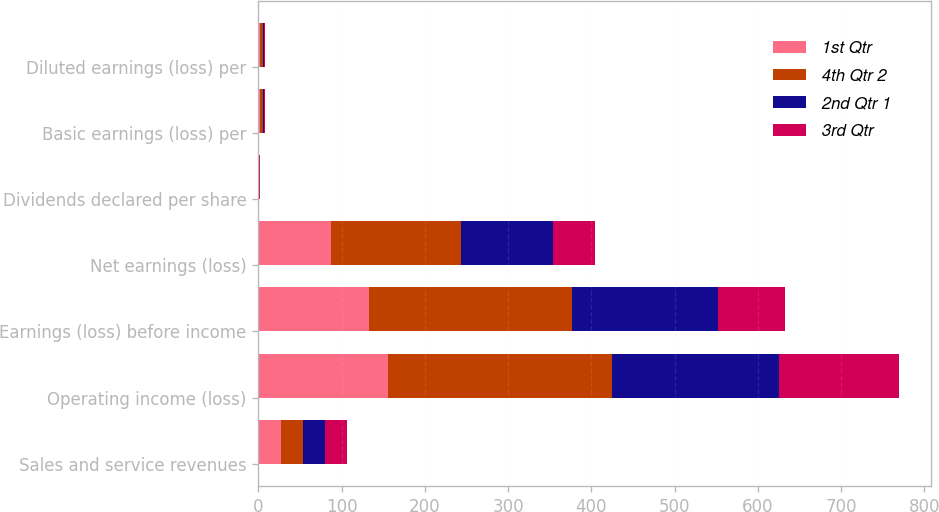Convert chart. <chart><loc_0><loc_0><loc_500><loc_500><stacked_bar_chart><ecel><fcel>Sales and service revenues<fcel>Operating income (loss)<fcel>Earnings (loss) before income<fcel>Net earnings (loss)<fcel>Dividends declared per share<fcel>Basic earnings (loss) per<fcel>Diluted earnings (loss) per<nl><fcel>1st Qtr<fcel>26.61<fcel>156<fcel>133<fcel>87<fcel>0.4<fcel>1.8<fcel>1.79<nl><fcel>4th Qtr 2<fcel>26.61<fcel>269<fcel>244<fcel>156<fcel>0.4<fcel>3.22<fcel>3.2<nl><fcel>2nd Qtr 1<fcel>26.61<fcel>200<fcel>175<fcel>111<fcel>0.4<fcel>2.31<fcel>2.29<nl><fcel>3rd Qtr<fcel>26.61<fcel>144<fcel>80<fcel>50<fcel>0.5<fcel>1.07<fcel>1.06<nl></chart> 